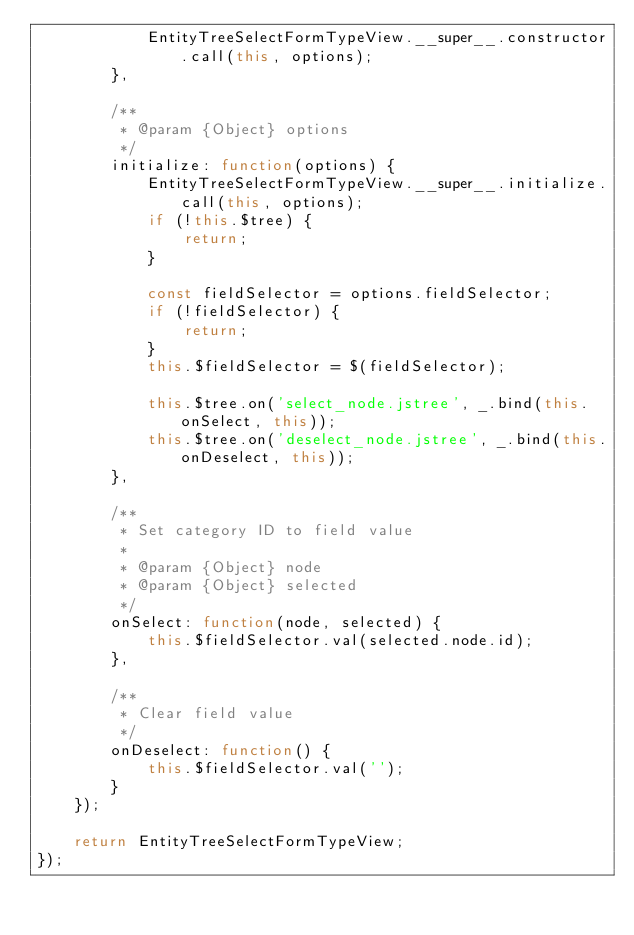Convert code to text. <code><loc_0><loc_0><loc_500><loc_500><_JavaScript_>            EntityTreeSelectFormTypeView.__super__.constructor.call(this, options);
        },

        /**
         * @param {Object} options
         */
        initialize: function(options) {
            EntityTreeSelectFormTypeView.__super__.initialize.call(this, options);
            if (!this.$tree) {
                return;
            }

            const fieldSelector = options.fieldSelector;
            if (!fieldSelector) {
                return;
            }
            this.$fieldSelector = $(fieldSelector);

            this.$tree.on('select_node.jstree', _.bind(this.onSelect, this));
            this.$tree.on('deselect_node.jstree', _.bind(this.onDeselect, this));
        },

        /**
         * Set category ID to field value
         *
         * @param {Object} node
         * @param {Object} selected
         */
        onSelect: function(node, selected) {
            this.$fieldSelector.val(selected.node.id);
        },

        /**
         * Clear field value
         */
        onDeselect: function() {
            this.$fieldSelector.val('');
        }
    });

    return EntityTreeSelectFormTypeView;
});
</code> 